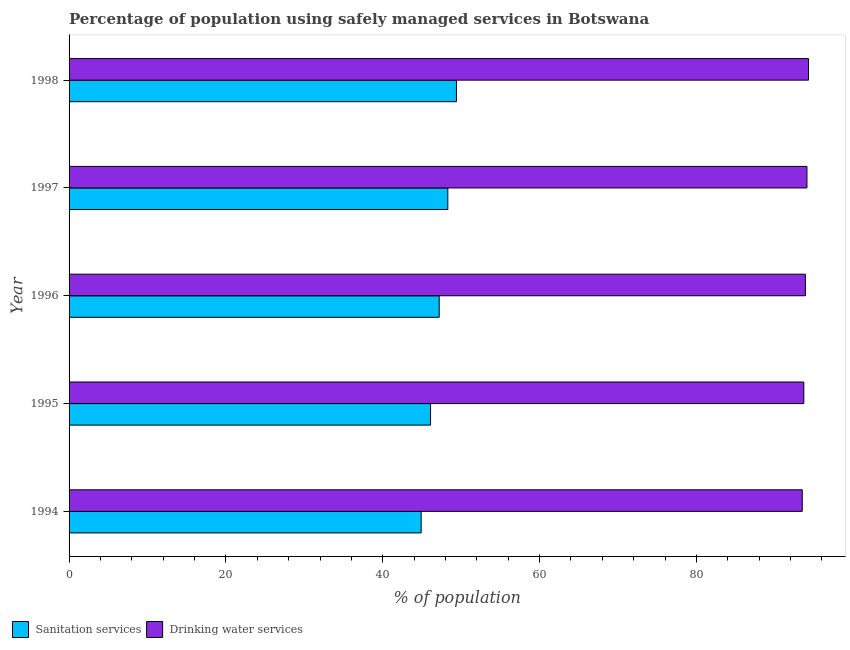How many different coloured bars are there?
Give a very brief answer. 2. Are the number of bars per tick equal to the number of legend labels?
Your answer should be very brief. Yes. Are the number of bars on each tick of the Y-axis equal?
Your answer should be very brief. Yes. How many bars are there on the 1st tick from the top?
Give a very brief answer. 2. What is the label of the 2nd group of bars from the top?
Offer a terse response. 1997. In how many cases, is the number of bars for a given year not equal to the number of legend labels?
Offer a very short reply. 0. What is the percentage of population who used drinking water services in 1997?
Offer a very short reply. 94.1. Across all years, what is the maximum percentage of population who used drinking water services?
Your answer should be very brief. 94.3. Across all years, what is the minimum percentage of population who used drinking water services?
Your answer should be compact. 93.5. What is the total percentage of population who used drinking water services in the graph?
Provide a succinct answer. 469.5. What is the difference between the percentage of population who used drinking water services in 1994 and that in 1997?
Your answer should be compact. -0.6. What is the difference between the percentage of population who used drinking water services in 1995 and the percentage of population who used sanitation services in 1996?
Your response must be concise. 46.5. What is the average percentage of population who used sanitation services per year?
Keep it short and to the point. 47.18. In the year 1996, what is the difference between the percentage of population who used sanitation services and percentage of population who used drinking water services?
Offer a very short reply. -46.7. In how many years, is the percentage of population who used sanitation services greater than 40 %?
Your response must be concise. 5. Is the percentage of population who used sanitation services in 1996 less than that in 1997?
Your answer should be compact. Yes. What is the difference between the highest and the second highest percentage of population who used sanitation services?
Offer a terse response. 1.1. In how many years, is the percentage of population who used sanitation services greater than the average percentage of population who used sanitation services taken over all years?
Your answer should be compact. 3. Is the sum of the percentage of population who used sanitation services in 1995 and 1998 greater than the maximum percentage of population who used drinking water services across all years?
Ensure brevity in your answer.  Yes. What does the 1st bar from the top in 1996 represents?
Your answer should be compact. Drinking water services. What does the 1st bar from the bottom in 1994 represents?
Provide a short and direct response. Sanitation services. Are all the bars in the graph horizontal?
Make the answer very short. Yes. How many years are there in the graph?
Provide a short and direct response. 5. Are the values on the major ticks of X-axis written in scientific E-notation?
Your answer should be very brief. No. Where does the legend appear in the graph?
Keep it short and to the point. Bottom left. How many legend labels are there?
Your answer should be compact. 2. How are the legend labels stacked?
Your answer should be compact. Horizontal. What is the title of the graph?
Provide a short and direct response. Percentage of population using safely managed services in Botswana. What is the label or title of the X-axis?
Provide a succinct answer. % of population. What is the % of population of Sanitation services in 1994?
Provide a short and direct response. 44.9. What is the % of population in Drinking water services in 1994?
Provide a succinct answer. 93.5. What is the % of population of Sanitation services in 1995?
Give a very brief answer. 46.1. What is the % of population in Drinking water services in 1995?
Ensure brevity in your answer.  93.7. What is the % of population in Sanitation services in 1996?
Provide a short and direct response. 47.2. What is the % of population in Drinking water services in 1996?
Offer a very short reply. 93.9. What is the % of population of Sanitation services in 1997?
Make the answer very short. 48.3. What is the % of population in Drinking water services in 1997?
Your answer should be compact. 94.1. What is the % of population of Sanitation services in 1998?
Provide a succinct answer. 49.4. What is the % of population of Drinking water services in 1998?
Your answer should be very brief. 94.3. Across all years, what is the maximum % of population of Sanitation services?
Give a very brief answer. 49.4. Across all years, what is the maximum % of population in Drinking water services?
Provide a succinct answer. 94.3. Across all years, what is the minimum % of population of Sanitation services?
Keep it short and to the point. 44.9. Across all years, what is the minimum % of population in Drinking water services?
Provide a short and direct response. 93.5. What is the total % of population in Sanitation services in the graph?
Provide a short and direct response. 235.9. What is the total % of population of Drinking water services in the graph?
Your answer should be very brief. 469.5. What is the difference between the % of population in Drinking water services in 1994 and that in 1995?
Make the answer very short. -0.2. What is the difference between the % of population of Drinking water services in 1994 and that in 1996?
Your answer should be very brief. -0.4. What is the difference between the % of population in Drinking water services in 1994 and that in 1997?
Provide a short and direct response. -0.6. What is the difference between the % of population of Sanitation services in 1994 and that in 1998?
Ensure brevity in your answer.  -4.5. What is the difference between the % of population of Sanitation services in 1996 and that in 1997?
Keep it short and to the point. -1.1. What is the difference between the % of population in Sanitation services in 1996 and that in 1998?
Give a very brief answer. -2.2. What is the difference between the % of population in Drinking water services in 1996 and that in 1998?
Your answer should be compact. -0.4. What is the difference between the % of population in Sanitation services in 1994 and the % of population in Drinking water services in 1995?
Ensure brevity in your answer.  -48.8. What is the difference between the % of population of Sanitation services in 1994 and the % of population of Drinking water services in 1996?
Give a very brief answer. -49. What is the difference between the % of population of Sanitation services in 1994 and the % of population of Drinking water services in 1997?
Your answer should be compact. -49.2. What is the difference between the % of population in Sanitation services in 1994 and the % of population in Drinking water services in 1998?
Provide a succinct answer. -49.4. What is the difference between the % of population of Sanitation services in 1995 and the % of population of Drinking water services in 1996?
Make the answer very short. -47.8. What is the difference between the % of population in Sanitation services in 1995 and the % of population in Drinking water services in 1997?
Provide a short and direct response. -48. What is the difference between the % of population of Sanitation services in 1995 and the % of population of Drinking water services in 1998?
Keep it short and to the point. -48.2. What is the difference between the % of population in Sanitation services in 1996 and the % of population in Drinking water services in 1997?
Offer a terse response. -46.9. What is the difference between the % of population of Sanitation services in 1996 and the % of population of Drinking water services in 1998?
Ensure brevity in your answer.  -47.1. What is the difference between the % of population in Sanitation services in 1997 and the % of population in Drinking water services in 1998?
Your answer should be very brief. -46. What is the average % of population in Sanitation services per year?
Offer a very short reply. 47.18. What is the average % of population of Drinking water services per year?
Keep it short and to the point. 93.9. In the year 1994, what is the difference between the % of population in Sanitation services and % of population in Drinking water services?
Make the answer very short. -48.6. In the year 1995, what is the difference between the % of population in Sanitation services and % of population in Drinking water services?
Your answer should be very brief. -47.6. In the year 1996, what is the difference between the % of population of Sanitation services and % of population of Drinking water services?
Offer a very short reply. -46.7. In the year 1997, what is the difference between the % of population in Sanitation services and % of population in Drinking water services?
Make the answer very short. -45.8. In the year 1998, what is the difference between the % of population in Sanitation services and % of population in Drinking water services?
Provide a succinct answer. -44.9. What is the ratio of the % of population in Sanitation services in 1994 to that in 1995?
Your answer should be very brief. 0.97. What is the ratio of the % of population in Drinking water services in 1994 to that in 1995?
Offer a terse response. 1. What is the ratio of the % of population in Sanitation services in 1994 to that in 1996?
Keep it short and to the point. 0.95. What is the ratio of the % of population of Drinking water services in 1994 to that in 1996?
Keep it short and to the point. 1. What is the ratio of the % of population of Sanitation services in 1994 to that in 1997?
Provide a short and direct response. 0.93. What is the ratio of the % of population of Drinking water services in 1994 to that in 1997?
Offer a very short reply. 0.99. What is the ratio of the % of population in Sanitation services in 1994 to that in 1998?
Offer a very short reply. 0.91. What is the ratio of the % of population of Drinking water services in 1994 to that in 1998?
Your answer should be compact. 0.99. What is the ratio of the % of population in Sanitation services in 1995 to that in 1996?
Offer a very short reply. 0.98. What is the ratio of the % of population in Drinking water services in 1995 to that in 1996?
Make the answer very short. 1. What is the ratio of the % of population in Sanitation services in 1995 to that in 1997?
Make the answer very short. 0.95. What is the ratio of the % of population of Drinking water services in 1995 to that in 1997?
Make the answer very short. 1. What is the ratio of the % of population in Sanitation services in 1995 to that in 1998?
Provide a succinct answer. 0.93. What is the ratio of the % of population of Sanitation services in 1996 to that in 1997?
Your answer should be very brief. 0.98. What is the ratio of the % of population in Sanitation services in 1996 to that in 1998?
Provide a succinct answer. 0.96. What is the ratio of the % of population in Sanitation services in 1997 to that in 1998?
Ensure brevity in your answer.  0.98. What is the difference between the highest and the second highest % of population in Sanitation services?
Provide a succinct answer. 1.1. What is the difference between the highest and the lowest % of population in Drinking water services?
Offer a terse response. 0.8. 